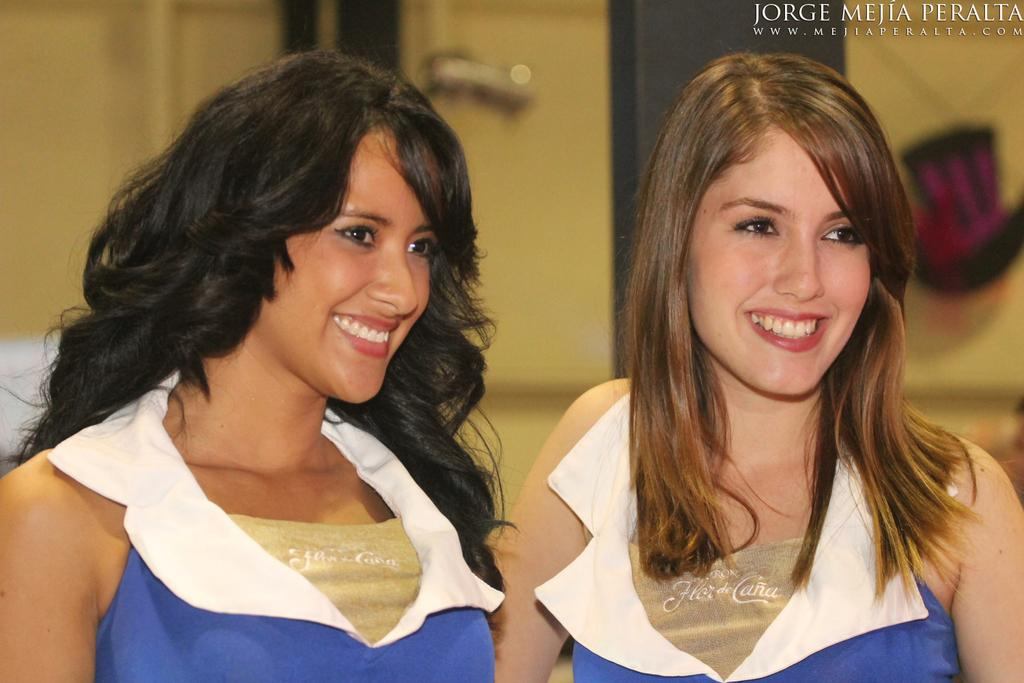Who can be seen in the foreground of the image? There are there any girls in the image? What else is present in the foreground of the image besides the girls? There is text in the foreground of the image. Can you see any news about the ocean on fire in the image? No, there is no news or reference to an ocean on fire in the image. 